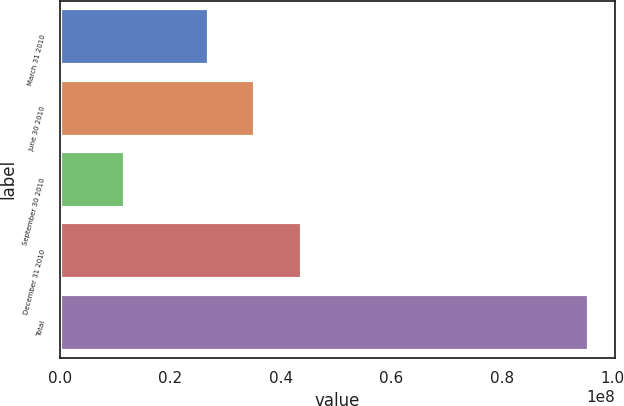<chart> <loc_0><loc_0><loc_500><loc_500><bar_chart><fcel>March 31 2010<fcel>June 30 2010<fcel>September 30 2010<fcel>December 31 2010<fcel>Total<nl><fcel>2.69853e+07<fcel>3.53749e+07<fcel>1.18287e+07<fcel>4.37644e+07<fcel>9.57243e+07<nl></chart> 